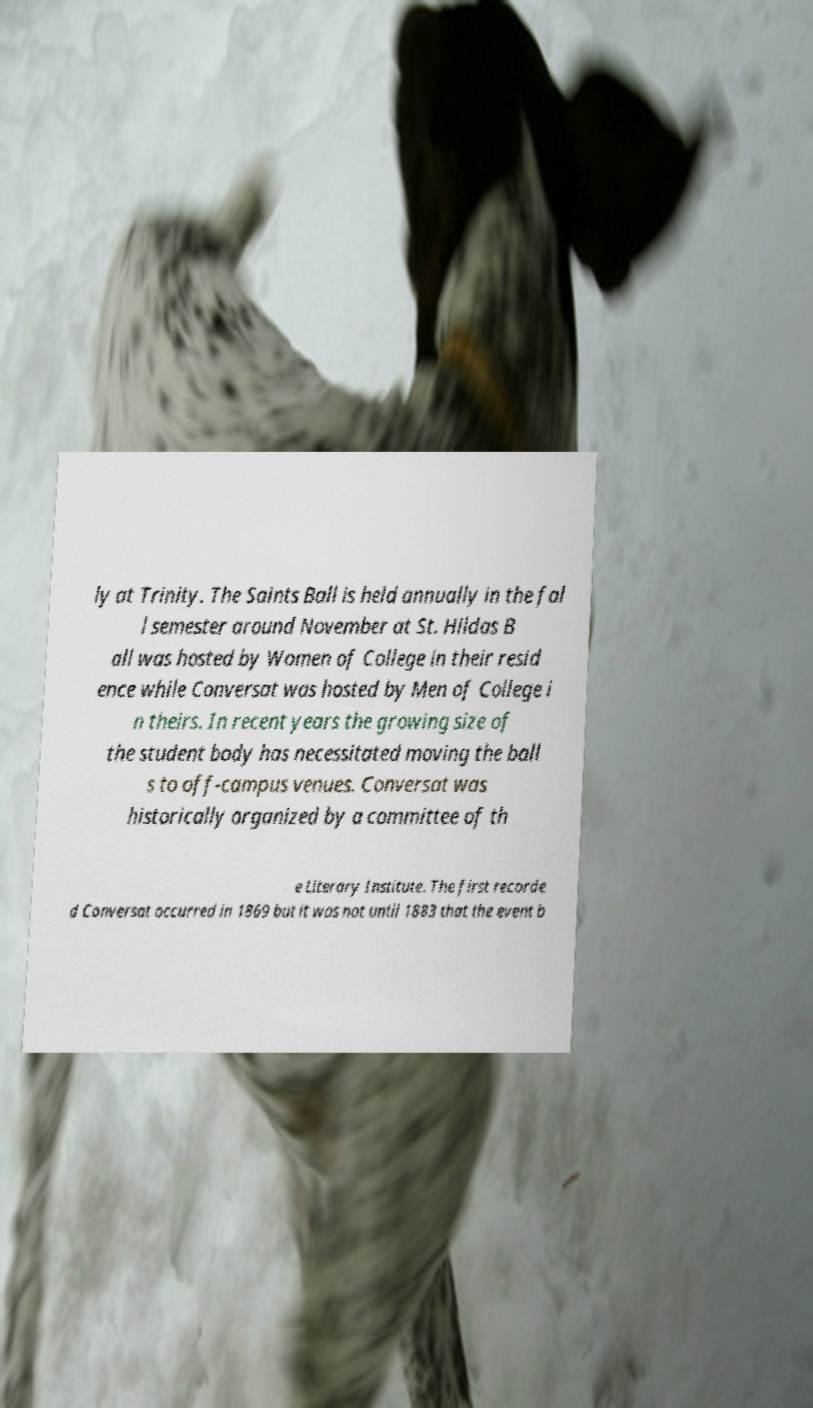For documentation purposes, I need the text within this image transcribed. Could you provide that? ly at Trinity. The Saints Ball is held annually in the fal l semester around November at St. Hildas B all was hosted by Women of College in their resid ence while Conversat was hosted by Men of College i n theirs. In recent years the growing size of the student body has necessitated moving the ball s to off-campus venues. Conversat was historically organized by a committee of th e Literary Institute. The first recorde d Conversat occurred in 1869 but it was not until 1883 that the event b 